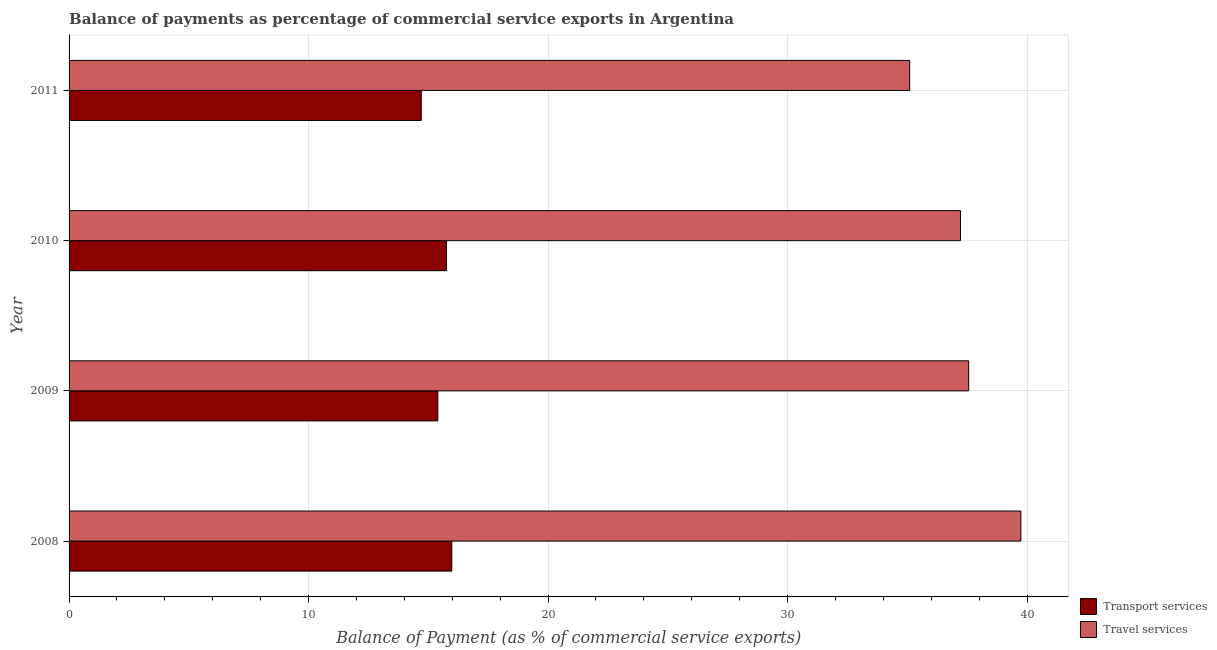How many different coloured bars are there?
Ensure brevity in your answer.  2. Are the number of bars per tick equal to the number of legend labels?
Provide a short and direct response. Yes. Are the number of bars on each tick of the Y-axis equal?
Offer a very short reply. Yes. How many bars are there on the 1st tick from the top?
Keep it short and to the point. 2. How many bars are there on the 1st tick from the bottom?
Offer a very short reply. 2. What is the label of the 1st group of bars from the top?
Give a very brief answer. 2011. What is the balance of payments of travel services in 2011?
Your response must be concise. 35.1. Across all years, what is the maximum balance of payments of travel services?
Keep it short and to the point. 39.74. Across all years, what is the minimum balance of payments of travel services?
Keep it short and to the point. 35.1. In which year was the balance of payments of transport services maximum?
Your response must be concise. 2008. In which year was the balance of payments of transport services minimum?
Offer a very short reply. 2011. What is the total balance of payments of travel services in the graph?
Offer a terse response. 149.62. What is the difference between the balance of payments of travel services in 2010 and that in 2011?
Give a very brief answer. 2.12. What is the difference between the balance of payments of transport services in 2008 and the balance of payments of travel services in 2009?
Provide a short and direct response. -21.58. What is the average balance of payments of travel services per year?
Make the answer very short. 37.41. In the year 2010, what is the difference between the balance of payments of transport services and balance of payments of travel services?
Provide a short and direct response. -21.46. In how many years, is the balance of payments of transport services greater than 20 %?
Make the answer very short. 0. Is the difference between the balance of payments of transport services in 2008 and 2010 greater than the difference between the balance of payments of travel services in 2008 and 2010?
Keep it short and to the point. No. What is the difference between the highest and the second highest balance of payments of travel services?
Your response must be concise. 2.18. What is the difference between the highest and the lowest balance of payments of transport services?
Keep it short and to the point. 1.27. In how many years, is the balance of payments of travel services greater than the average balance of payments of travel services taken over all years?
Your answer should be compact. 2. What does the 1st bar from the top in 2008 represents?
Ensure brevity in your answer.  Travel services. What does the 2nd bar from the bottom in 2009 represents?
Make the answer very short. Travel services. How many bars are there?
Give a very brief answer. 8. How many years are there in the graph?
Provide a succinct answer. 4. What is the difference between two consecutive major ticks on the X-axis?
Your answer should be very brief. 10. Are the values on the major ticks of X-axis written in scientific E-notation?
Provide a succinct answer. No. Does the graph contain any zero values?
Offer a terse response. No. How many legend labels are there?
Provide a succinct answer. 2. How are the legend labels stacked?
Provide a succinct answer. Vertical. What is the title of the graph?
Keep it short and to the point. Balance of payments as percentage of commercial service exports in Argentina. Does "% of GNI" appear as one of the legend labels in the graph?
Your answer should be very brief. No. What is the label or title of the X-axis?
Keep it short and to the point. Balance of Payment (as % of commercial service exports). What is the Balance of Payment (as % of commercial service exports) of Transport services in 2008?
Your answer should be compact. 15.98. What is the Balance of Payment (as % of commercial service exports) of Travel services in 2008?
Keep it short and to the point. 39.74. What is the Balance of Payment (as % of commercial service exports) of Transport services in 2009?
Offer a very short reply. 15.4. What is the Balance of Payment (as % of commercial service exports) of Travel services in 2009?
Offer a terse response. 37.56. What is the Balance of Payment (as % of commercial service exports) of Transport services in 2010?
Offer a very short reply. 15.76. What is the Balance of Payment (as % of commercial service exports) in Travel services in 2010?
Give a very brief answer. 37.22. What is the Balance of Payment (as % of commercial service exports) of Transport services in 2011?
Give a very brief answer. 14.7. What is the Balance of Payment (as % of commercial service exports) of Travel services in 2011?
Offer a terse response. 35.1. Across all years, what is the maximum Balance of Payment (as % of commercial service exports) of Transport services?
Ensure brevity in your answer.  15.98. Across all years, what is the maximum Balance of Payment (as % of commercial service exports) in Travel services?
Ensure brevity in your answer.  39.74. Across all years, what is the minimum Balance of Payment (as % of commercial service exports) of Transport services?
Provide a short and direct response. 14.7. Across all years, what is the minimum Balance of Payment (as % of commercial service exports) of Travel services?
Give a very brief answer. 35.1. What is the total Balance of Payment (as % of commercial service exports) in Transport services in the graph?
Give a very brief answer. 61.84. What is the total Balance of Payment (as % of commercial service exports) in Travel services in the graph?
Your answer should be very brief. 149.62. What is the difference between the Balance of Payment (as % of commercial service exports) of Transport services in 2008 and that in 2009?
Keep it short and to the point. 0.58. What is the difference between the Balance of Payment (as % of commercial service exports) in Travel services in 2008 and that in 2009?
Give a very brief answer. 2.18. What is the difference between the Balance of Payment (as % of commercial service exports) of Transport services in 2008 and that in 2010?
Ensure brevity in your answer.  0.22. What is the difference between the Balance of Payment (as % of commercial service exports) in Travel services in 2008 and that in 2010?
Your response must be concise. 2.52. What is the difference between the Balance of Payment (as % of commercial service exports) of Transport services in 2008 and that in 2011?
Offer a terse response. 1.27. What is the difference between the Balance of Payment (as % of commercial service exports) in Travel services in 2008 and that in 2011?
Provide a succinct answer. 4.64. What is the difference between the Balance of Payment (as % of commercial service exports) of Transport services in 2009 and that in 2010?
Ensure brevity in your answer.  -0.36. What is the difference between the Balance of Payment (as % of commercial service exports) of Travel services in 2009 and that in 2010?
Offer a very short reply. 0.34. What is the difference between the Balance of Payment (as % of commercial service exports) in Transport services in 2009 and that in 2011?
Your response must be concise. 0.69. What is the difference between the Balance of Payment (as % of commercial service exports) of Travel services in 2009 and that in 2011?
Keep it short and to the point. 2.46. What is the difference between the Balance of Payment (as % of commercial service exports) of Transport services in 2010 and that in 2011?
Offer a terse response. 1.06. What is the difference between the Balance of Payment (as % of commercial service exports) in Travel services in 2010 and that in 2011?
Give a very brief answer. 2.12. What is the difference between the Balance of Payment (as % of commercial service exports) of Transport services in 2008 and the Balance of Payment (as % of commercial service exports) of Travel services in 2009?
Your answer should be very brief. -21.58. What is the difference between the Balance of Payment (as % of commercial service exports) in Transport services in 2008 and the Balance of Payment (as % of commercial service exports) in Travel services in 2010?
Offer a very short reply. -21.24. What is the difference between the Balance of Payment (as % of commercial service exports) in Transport services in 2008 and the Balance of Payment (as % of commercial service exports) in Travel services in 2011?
Provide a succinct answer. -19.12. What is the difference between the Balance of Payment (as % of commercial service exports) of Transport services in 2009 and the Balance of Payment (as % of commercial service exports) of Travel services in 2010?
Your answer should be very brief. -21.82. What is the difference between the Balance of Payment (as % of commercial service exports) in Transport services in 2009 and the Balance of Payment (as % of commercial service exports) in Travel services in 2011?
Your response must be concise. -19.7. What is the difference between the Balance of Payment (as % of commercial service exports) in Transport services in 2010 and the Balance of Payment (as % of commercial service exports) in Travel services in 2011?
Provide a succinct answer. -19.34. What is the average Balance of Payment (as % of commercial service exports) of Transport services per year?
Your answer should be very brief. 15.46. What is the average Balance of Payment (as % of commercial service exports) in Travel services per year?
Offer a terse response. 37.41. In the year 2008, what is the difference between the Balance of Payment (as % of commercial service exports) of Transport services and Balance of Payment (as % of commercial service exports) of Travel services?
Provide a succinct answer. -23.76. In the year 2009, what is the difference between the Balance of Payment (as % of commercial service exports) in Transport services and Balance of Payment (as % of commercial service exports) in Travel services?
Your answer should be compact. -22.16. In the year 2010, what is the difference between the Balance of Payment (as % of commercial service exports) of Transport services and Balance of Payment (as % of commercial service exports) of Travel services?
Ensure brevity in your answer.  -21.46. In the year 2011, what is the difference between the Balance of Payment (as % of commercial service exports) of Transport services and Balance of Payment (as % of commercial service exports) of Travel services?
Offer a terse response. -20.39. What is the ratio of the Balance of Payment (as % of commercial service exports) in Transport services in 2008 to that in 2009?
Give a very brief answer. 1.04. What is the ratio of the Balance of Payment (as % of commercial service exports) of Travel services in 2008 to that in 2009?
Offer a terse response. 1.06. What is the ratio of the Balance of Payment (as % of commercial service exports) of Transport services in 2008 to that in 2010?
Offer a terse response. 1.01. What is the ratio of the Balance of Payment (as % of commercial service exports) in Travel services in 2008 to that in 2010?
Keep it short and to the point. 1.07. What is the ratio of the Balance of Payment (as % of commercial service exports) of Transport services in 2008 to that in 2011?
Your response must be concise. 1.09. What is the ratio of the Balance of Payment (as % of commercial service exports) of Travel services in 2008 to that in 2011?
Your answer should be very brief. 1.13. What is the ratio of the Balance of Payment (as % of commercial service exports) in Transport services in 2009 to that in 2010?
Keep it short and to the point. 0.98. What is the ratio of the Balance of Payment (as % of commercial service exports) of Travel services in 2009 to that in 2010?
Provide a short and direct response. 1.01. What is the ratio of the Balance of Payment (as % of commercial service exports) of Transport services in 2009 to that in 2011?
Provide a short and direct response. 1.05. What is the ratio of the Balance of Payment (as % of commercial service exports) in Travel services in 2009 to that in 2011?
Provide a succinct answer. 1.07. What is the ratio of the Balance of Payment (as % of commercial service exports) of Transport services in 2010 to that in 2011?
Provide a succinct answer. 1.07. What is the ratio of the Balance of Payment (as % of commercial service exports) in Travel services in 2010 to that in 2011?
Provide a short and direct response. 1.06. What is the difference between the highest and the second highest Balance of Payment (as % of commercial service exports) in Transport services?
Offer a terse response. 0.22. What is the difference between the highest and the second highest Balance of Payment (as % of commercial service exports) of Travel services?
Keep it short and to the point. 2.18. What is the difference between the highest and the lowest Balance of Payment (as % of commercial service exports) of Transport services?
Offer a terse response. 1.27. What is the difference between the highest and the lowest Balance of Payment (as % of commercial service exports) in Travel services?
Ensure brevity in your answer.  4.64. 